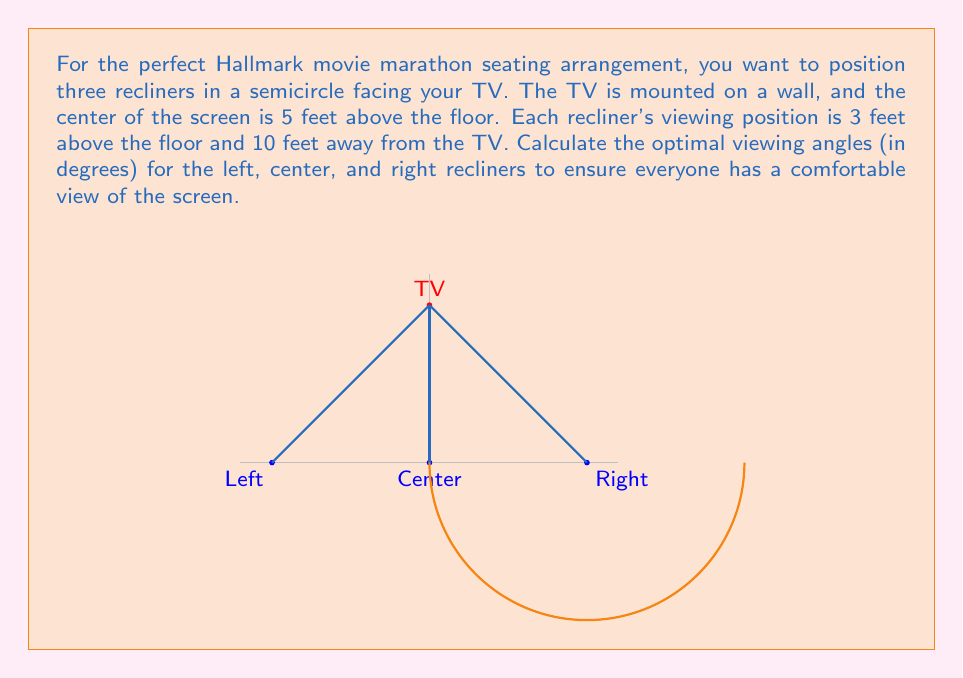Provide a solution to this math problem. Let's approach this step-by-step using vector-valued functions:

1) First, let's define our coordinate system. Place the origin at floor level, directly below the TV. The positive y-axis points upward, and the positive x-axis points to the right.

2) The TV position vector is:
   $$\vec{TV} = \begin{pmatrix} 0 \\ 5 \end{pmatrix}$$

3) The position vectors for the three recliners are:
   $$\vec{L} = \begin{pmatrix} -5 \\ 3 \end{pmatrix}, \quad \vec{C} = \begin{pmatrix} 0 \\ 3 \end{pmatrix}, \quad \vec{R} = \begin{pmatrix} 5 \\ 3 \end{pmatrix}$$

4) To find the viewing angles, we need to calculate the angle between the vertical line from each recliner to the TV.

5) For each recliner, we can use the dot product formula:
   $$\cos \theta = \frac{\vec{a} \cdot \vec{b}}{|\vec{a}||\vec{b}|}$$

   Where $\vec{a}$ is the vector from the recliner to the TV, and $\vec{b}$ is the vertical vector.

6) For the center recliner:
   $$\vec{a_C} = \vec{TV} - \vec{C} = \begin{pmatrix} 0 \\ 2 \end{pmatrix}$$
   $$\vec{b} = \begin{pmatrix} 0 \\ 1 \end{pmatrix}$$
   $$\cos \theta_C = \frac{0 \cdot 0 + 2 \cdot 1}{\sqrt{0^2 + 2^2} \cdot \sqrt{0^2 + 1^2}} = 1$$
   $$\theta_C = \arccos(1) = 0°$$

7) For the left recliner:
   $$\vec{a_L} = \vec{TV} - \vec{L} = \begin{pmatrix} 5 \\ 2 \end{pmatrix}$$
   $$\cos \theta_L = \frac{5 \cdot 0 + 2 \cdot 1}{\sqrt{5^2 + 2^2} \cdot \sqrt{0^2 + 1^2}} = \frac{2}{\sqrt{29}}$$
   $$\theta_L = \arccos(\frac{2}{\sqrt{29}}) \approx 68.20°$$

8) Due to symmetry, the right recliner will have the same angle as the left, but in the opposite direction.
Answer: Left: 68.20°, Center: 0°, Right: 68.20° 